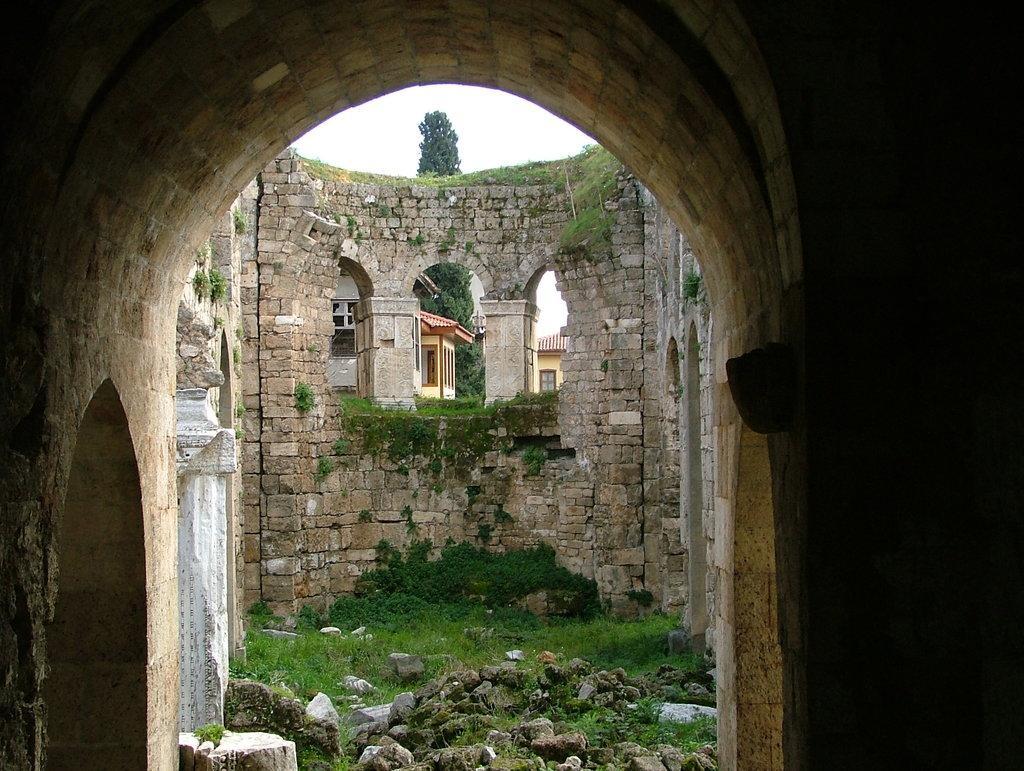How would you summarize this image in a sentence or two? This image is taken from inside the fort. In this image we can see there is a wall with bricks and there is a grass and rocks on the surface. In the background, we can see there are buildings, trees and the sky. 